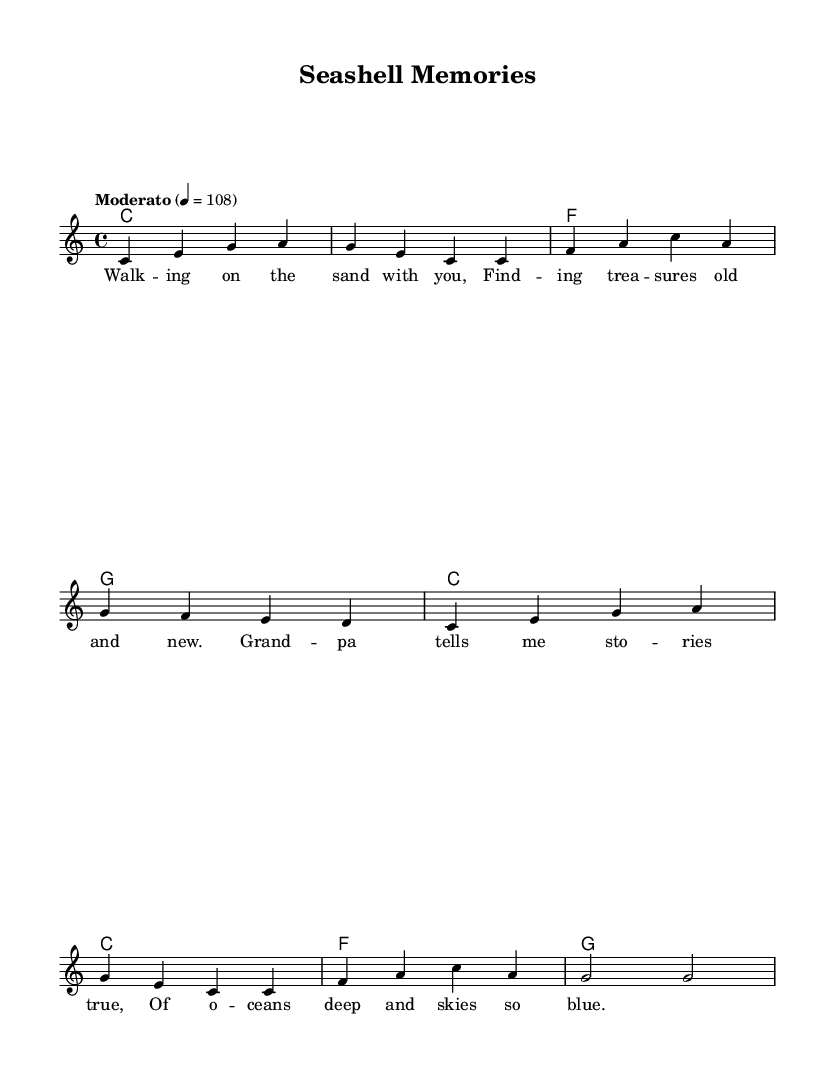What is the key signature of this music? The key signature is indicated at the beginning of the staff and shows there are no sharps or flats, meaning it is in C major.
Answer: C major What is the time signature of this music? The time signature is found right after the key signature at the beginning of the score and shows that there are four beats in each measure.
Answer: 4/4 What is the tempo marking for this piece? The tempo marking, placed at the beginning of the sheet music, indicates "Moderato" with the beat set at 108 for quarter notes, showing a moderate speed.
Answer: Moderato 4 = 108 How many measures are in the melody? By counting the segments separated by the vertical lines in the melody section, we find there are eight measures total.
Answer: Eight What is the first note of the melody? Looking at the first measure of the melody, we see that the first note is C, which is located on the bottom line of the staff.
Answer: C What chord is played in the second measure? The second measure of the harmonies section shows the chord C being played, as notated with the letter C under the staff.
Answer: C What is the overall theme of the lyrics? The lyrics speak about experiences at the beach, like finding treasures and sharing stories with a grandparent, highlighting intergenerational bonding.
Answer: Intergenerational bonding 